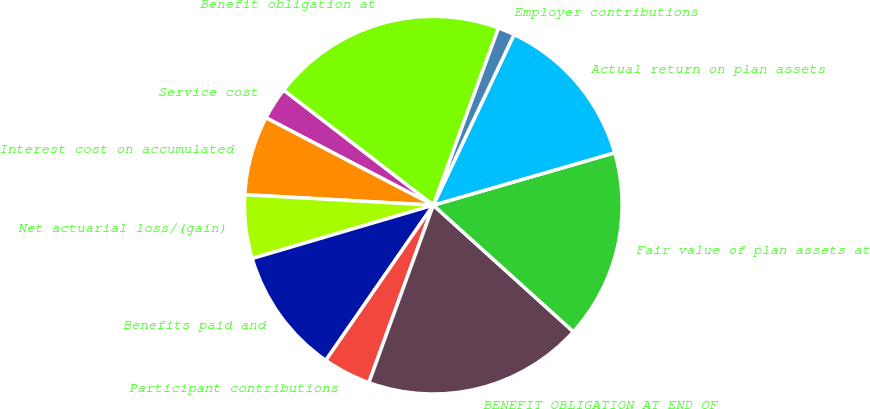Convert chart. <chart><loc_0><loc_0><loc_500><loc_500><pie_chart><fcel>Benefit obligation at<fcel>Service cost<fcel>Interest cost on accumulated<fcel>Net actuarial loss/(gain)<fcel>Benefits paid and<fcel>Participant contributions<fcel>BENEFIT OBLIGATION AT END OF<fcel>Fair value of plan assets at<fcel>Actual return on plan assets<fcel>Employer contributions<nl><fcel>20.19%<fcel>2.76%<fcel>6.78%<fcel>5.44%<fcel>10.8%<fcel>4.1%<fcel>18.85%<fcel>16.17%<fcel>13.49%<fcel>1.42%<nl></chart> 